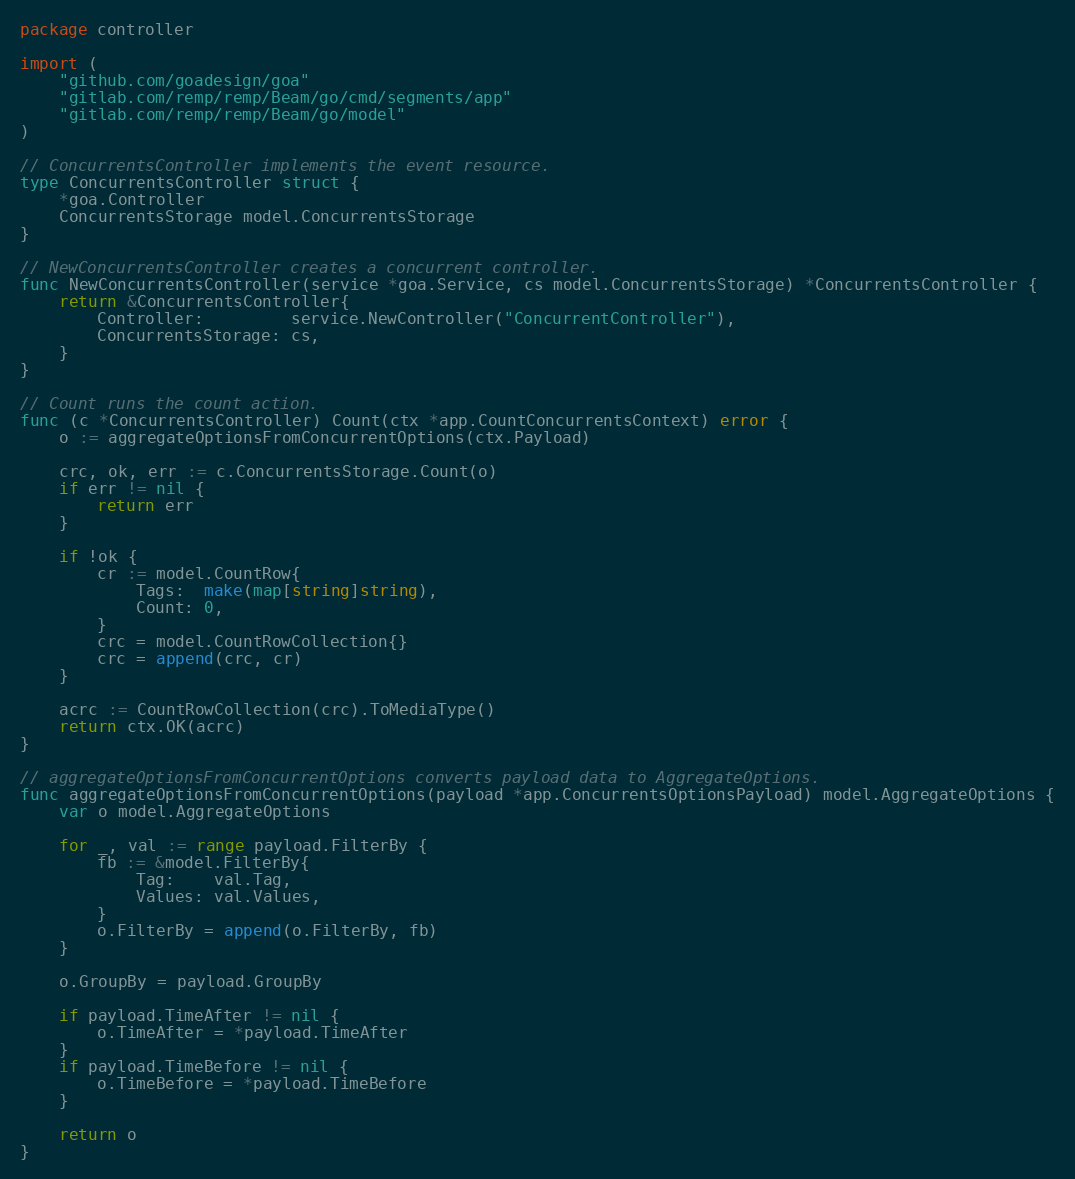Convert code to text. <code><loc_0><loc_0><loc_500><loc_500><_Go_>package controller

import (
	"github.com/goadesign/goa"
	"gitlab.com/remp/remp/Beam/go/cmd/segments/app"
	"gitlab.com/remp/remp/Beam/go/model"
)

// ConcurrentsController implements the event resource.
type ConcurrentsController struct {
	*goa.Controller
	ConcurrentsStorage model.ConcurrentsStorage
}

// NewConcurrentsController creates a concurrent controller.
func NewConcurrentsController(service *goa.Service, cs model.ConcurrentsStorage) *ConcurrentsController {
	return &ConcurrentsController{
		Controller:         service.NewController("ConcurrentController"),
		ConcurrentsStorage: cs,
	}
}

// Count runs the count action.
func (c *ConcurrentsController) Count(ctx *app.CountConcurrentsContext) error {
	o := aggregateOptionsFromConcurrentOptions(ctx.Payload)

	crc, ok, err := c.ConcurrentsStorage.Count(o)
	if err != nil {
		return err
	}

	if !ok {
		cr := model.CountRow{
			Tags:  make(map[string]string),
			Count: 0,
		}
		crc = model.CountRowCollection{}
		crc = append(crc, cr)
	}

	acrc := CountRowCollection(crc).ToMediaType()
	return ctx.OK(acrc)
}

// aggregateOptionsFromConcurrentOptions converts payload data to AggregateOptions.
func aggregateOptionsFromConcurrentOptions(payload *app.ConcurrentsOptionsPayload) model.AggregateOptions {
	var o model.AggregateOptions

	for _, val := range payload.FilterBy {
		fb := &model.FilterBy{
			Tag:    val.Tag,
			Values: val.Values,
		}
		o.FilterBy = append(o.FilterBy, fb)
	}

	o.GroupBy = payload.GroupBy

	if payload.TimeAfter != nil {
		o.TimeAfter = *payload.TimeAfter
	}
	if payload.TimeBefore != nil {
		o.TimeBefore = *payload.TimeBefore
	}

	return o
}
</code> 